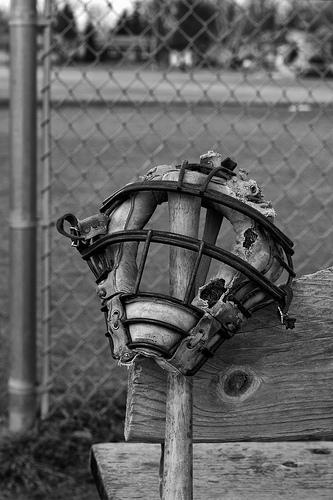In the image, what is leaning against the wooden bench? A wooden baseball bat is leaning against the wooden bench. Identify the main object resting on the wooden bench in the image. A baseball catcher mask is resting on the wooden bench in the image. Analyze the object interactions happening between the baseball catcher mask and the wooden bench. The baseball catcher mask is placed on the wooden bench, signifying that they are related to the activity of a baseball game or the player's break time. In a more informal description, tell me what part of the mask has wear marks. The wear spit on the mask has some marks, probably from use or aging. What is the general mood or sentiment expressed in the image, considering the objects present? The general mood expressed in the image is focused, prepared, or relaxed, as the objects are related to a baseball game and resting during a break. Please describe the location of grass growing in the image. Grass is growing around a pole and by the fence in the image. List three objects found in the scene relating to a baseball game. A baseball catcher mask, wooden ball bat, and a baseball white base are present in the image. Points out what type of fence is shown in the picture? A chain link fence is shown in the picture. What is the predominant type of material mentioned in the objects found in the image? Wooden material is predominantly mentioned in the objects found in the image. 